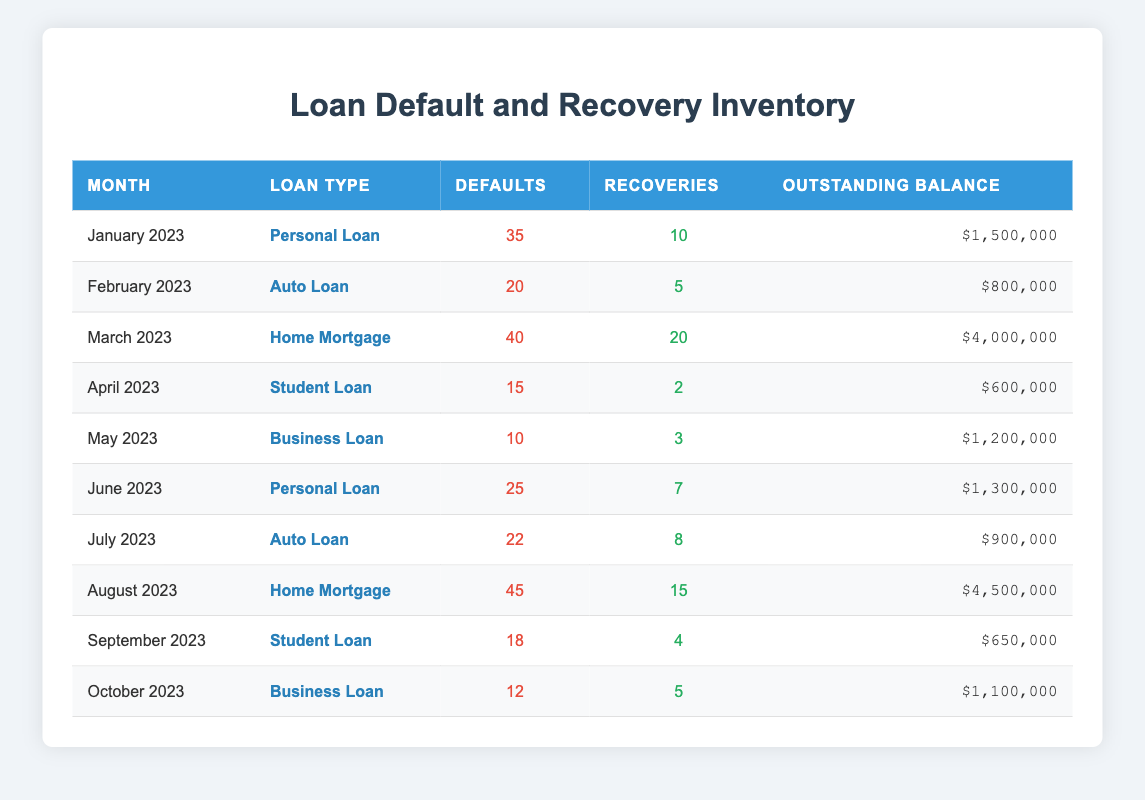What was the total number of defaults in August 2023? In August 2023, the number of defaults for Home Mortgage loans is provided in the table as 45. This is the only entry for that month, so no other data is needed for this calculation.
Answer: 45 What is the outstanding balance for Personal Loans in June 2023? The table shows that the outstanding balance for Personal Loans in June 2023 is $1,300,000, so we can directly retrieve this value from the table.
Answer: $1,300,000 How many recoveries were made in total for Auto Loans across the months listed? We need to sum the recoveries specifically for Auto Loans: in February 2023, recoveries were 5; in July 2023, recoveries were 8. Adding these gives 5 + 8 = 13.
Answer: 13 Are there any months where the number of defaults was greater than recoveries for Home Mortgages? Looking at the data for Home Mortgages, we see the defaults were 40 in March 2023 and 45 in August 2023, whereas the recoveries were 20 and 15, respectively. Both months have more defaults than recoveries.
Answer: Yes What was the overall change in defaults from January 2023 to October 2023 for Personal Loans? In January 2023, the number of defaults for Personal Loans was 35, and in June 2023, it decreased to 25. We can calculate the change as 25 (in June) - 35 (in January) = -10, indicating there were 10 fewer defaults in June compared to January.
Answer: -10 Which loan type experienced the highest number of defaults in September 2023? Looking at September 2023, the only loan type listed is Student Loan, with 18 defaults. We check all other months and see no other type exceeds this number, confirming it's the highest for that month.
Answer: Student Loan Calculate the average outstanding balance for Business Loans. The table lists the outstanding balances for Business Loans as $1,200,000 for May 2023 and $1,100,000 for October 2023. The average is calculated by adding these two balances: $1,200,000 + $1,100,000 = $2,300,000, and then dividing by 2 (the number of entries), which equals $1,150,000.
Answer: $1,150,000 Did more recoveries occur in April 2023 than in June 2023? In April 2023, there were 2 recoveries for Student Loans, while in June 2023, there were 7 recoveries for Personal Loans. Since 7 is greater than 2, we conclude that more recoveries occurred in June.
Answer: Yes How many more defaults did Home Mortgages have than Student Loans in March 2023? For March 2023, Home Mortgages had 40 defaults, while Student Loans had 0 defaults listed for that month. The difference is calculated as 40 - 0 = 40, meaning Home Mortgages had 40 more defaults.
Answer: 40 